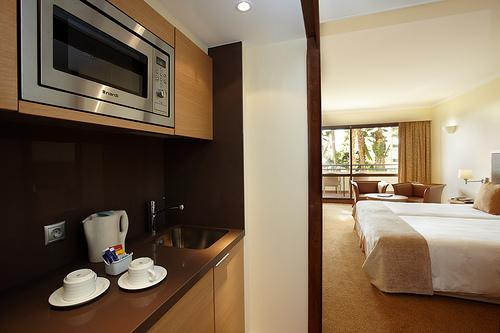What is under the upside-down coffee mugs in the image? White saucers can be seen placed under the upside-down coffee mugs. Mention any bedding items present in the image and their colors. There is a white bedspread, a tan blanket at the foot, and brown and white bed comforter on the bed. Write one sentence describing what's placed on the counter and how it looks. There is a white pitcher sitting on the dark brown counter, along with an upside-down coffee mug and a saucer. What type of window covering is present in the image and what color is it? There are brown drapes on the glass door and long curtains on the window. What type of appliance is mounted in a cabinet, and what color is its door? A silver built-in microwave is mounted in a cabinet, with a black door. Describe the setting near the window in the image. There is a table and chairs near the window, with a sliding glass door behind them, and palm trees visible outside. List two items associated with coffee drinking that are visible in the image. There are upside-down coffee mugs and a ceramic holder containing packets. Identify the type of room shown in the image and one key feature of it. The image shows a hotel room with a kitchenette, featuring a built-in silver microwave. Identify the various cabinet-related items in the image, including color and any additional features. There are brown wooden cabinets with a silver handle and a silver metallic water faucet present in the image. Where in the room is a lamp situated, and describe its appearance? There is a lamp on the wall with a white shade beside the bed. 